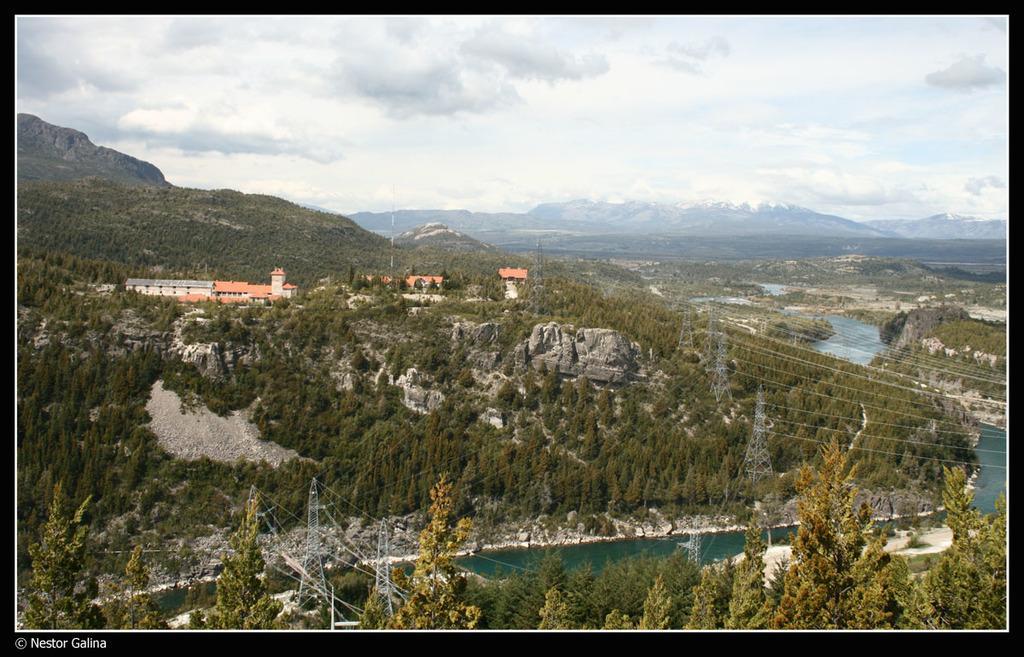Please provide a concise description of this image. This is an aerial view image, there is a canal on left side and buildings on the right side, in the back there are hills and above its sky with clouds. 